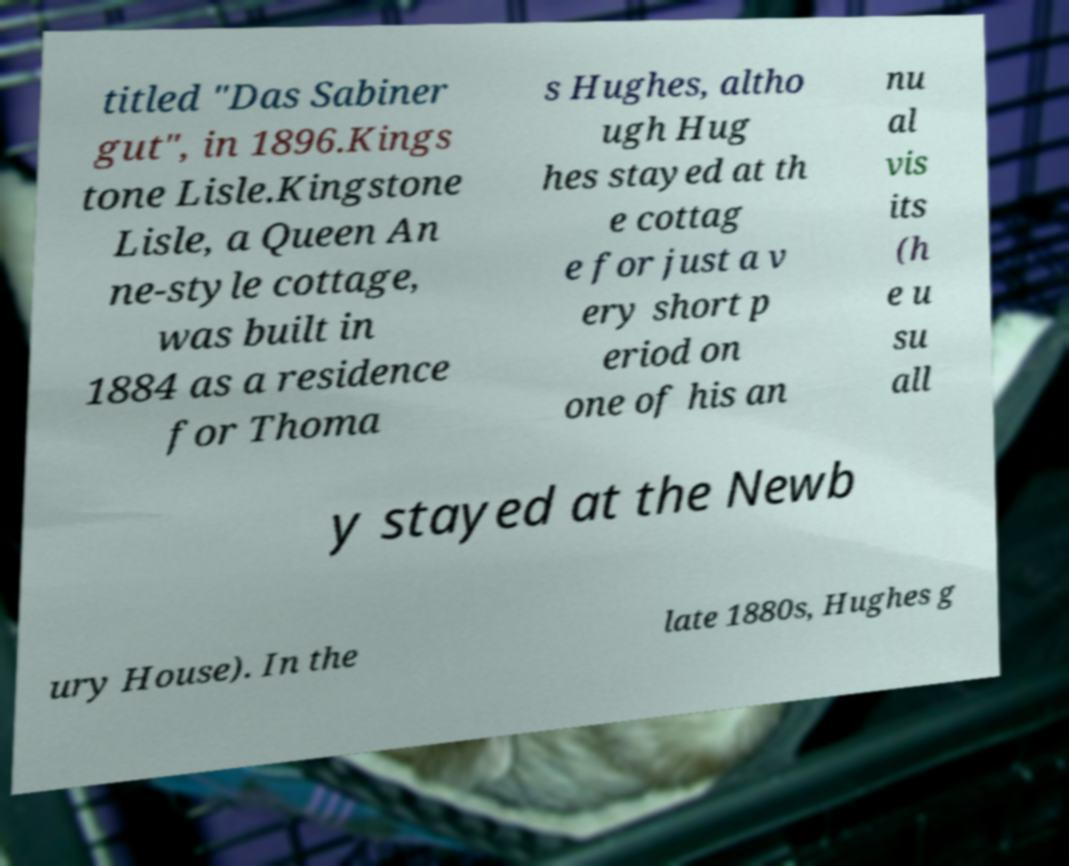Can you read and provide the text displayed in the image?This photo seems to have some interesting text. Can you extract and type it out for me? titled "Das Sabiner gut", in 1896.Kings tone Lisle.Kingstone Lisle, a Queen An ne-style cottage, was built in 1884 as a residence for Thoma s Hughes, altho ugh Hug hes stayed at th e cottag e for just a v ery short p eriod on one of his an nu al vis its (h e u su all y stayed at the Newb ury House). In the late 1880s, Hughes g 